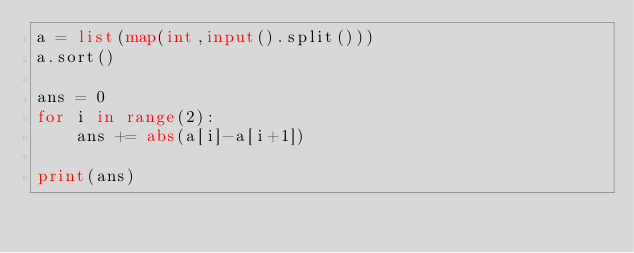Convert code to text. <code><loc_0><loc_0><loc_500><loc_500><_Python_>a = list(map(int,input().split()))
a.sort()

ans = 0
for i in range(2):
    ans += abs(a[i]-a[i+1])

print(ans)</code> 